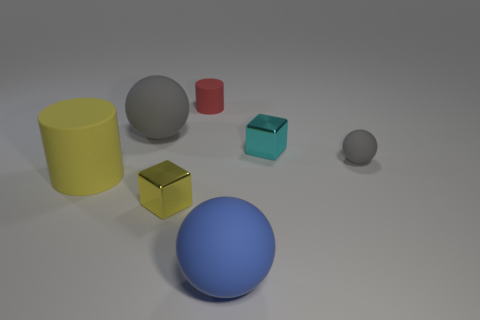Is the color of the small block left of the big blue matte object the same as the big rubber cylinder?
Keep it short and to the point. Yes. How many tiny metal blocks are the same color as the large matte cylinder?
Keep it short and to the point. 1. How many things are big things behind the blue matte ball or small metallic things left of the small red matte cylinder?
Provide a short and direct response. 3. What is the shape of the blue matte object that is the same size as the yellow cylinder?
Ensure brevity in your answer.  Sphere. There is a tiny rubber object that is right of the shiny cube that is behind the rubber cylinder that is to the left of the yellow metal cube; what is its shape?
Offer a very short reply. Sphere. Is the number of small yellow things to the right of the blue rubber thing the same as the number of small yellow matte objects?
Keep it short and to the point. Yes. Do the yellow rubber cylinder and the cyan cube have the same size?
Your answer should be very brief. No. What number of shiny objects are either big yellow things or large cyan objects?
Your answer should be very brief. 0. What is the material of the yellow cylinder that is the same size as the blue ball?
Keep it short and to the point. Rubber. What number of other objects are the same material as the cyan object?
Offer a terse response. 1. 